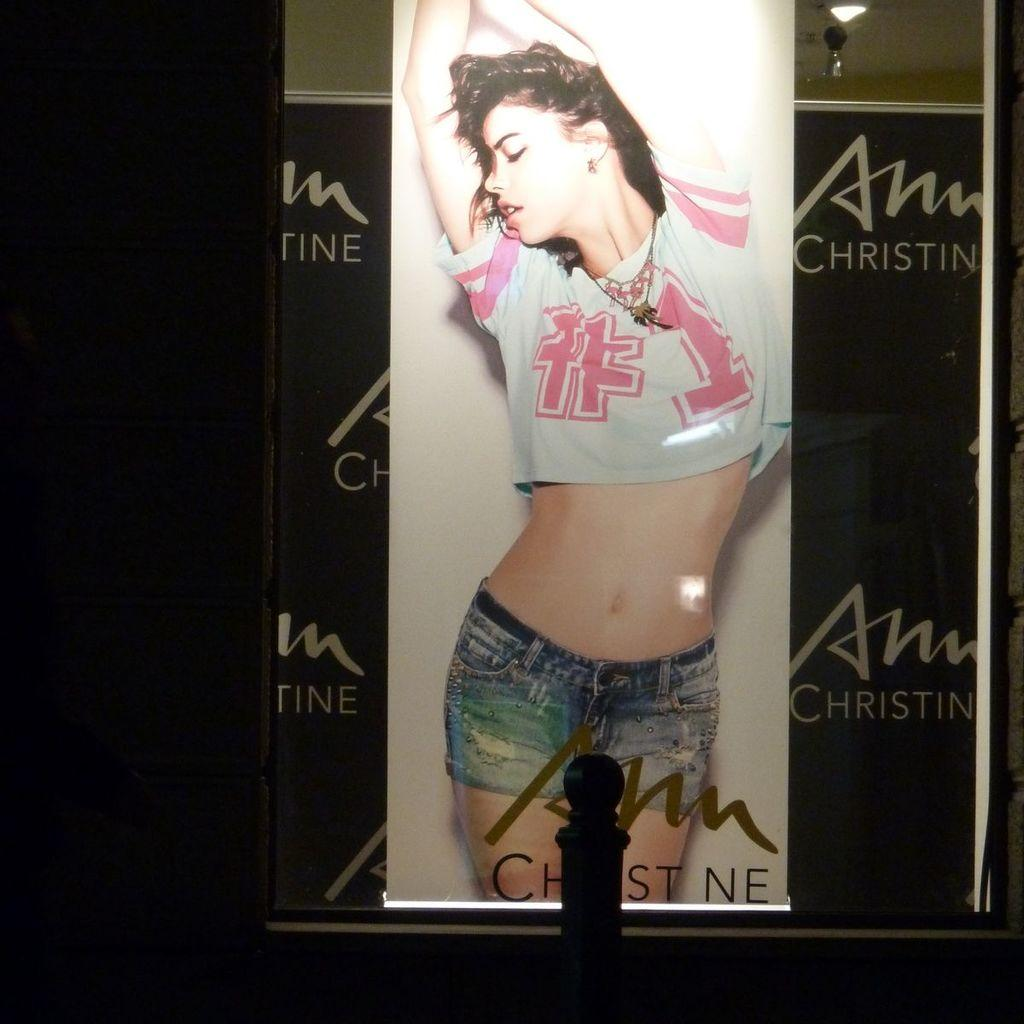<image>
Summarize the visual content of the image. A person wearing blue jean shorts with a t-shirt with the number one sign in the fron in red letters. 